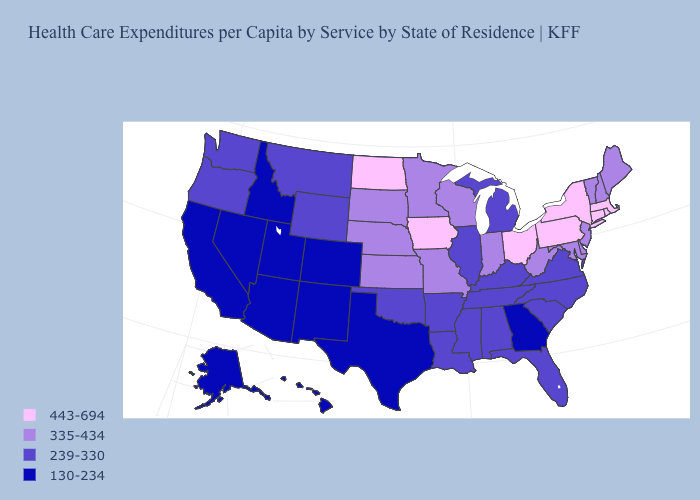What is the value of Colorado?
Quick response, please. 130-234. Name the states that have a value in the range 239-330?
Be succinct. Alabama, Arkansas, Florida, Illinois, Kentucky, Louisiana, Michigan, Mississippi, Montana, North Carolina, Oklahoma, Oregon, South Carolina, Tennessee, Virginia, Washington, Wyoming. Does the map have missing data?
Concise answer only. No. Which states have the lowest value in the USA?
Give a very brief answer. Alaska, Arizona, California, Colorado, Georgia, Hawaii, Idaho, Nevada, New Mexico, Texas, Utah. What is the value of Wisconsin?
Write a very short answer. 335-434. Does the map have missing data?
Concise answer only. No. What is the value of Iowa?
Answer briefly. 443-694. Which states have the lowest value in the South?
Answer briefly. Georgia, Texas. Among the states that border North Dakota , does South Dakota have the highest value?
Short answer required. Yes. Does the first symbol in the legend represent the smallest category?
Keep it brief. No. What is the value of North Dakota?
Give a very brief answer. 443-694. What is the value of New Hampshire?
Write a very short answer. 335-434. Does Tennessee have the highest value in the USA?
Answer briefly. No. Does New York have the highest value in the USA?
Keep it brief. Yes. What is the highest value in states that border North Dakota?
Write a very short answer. 335-434. 